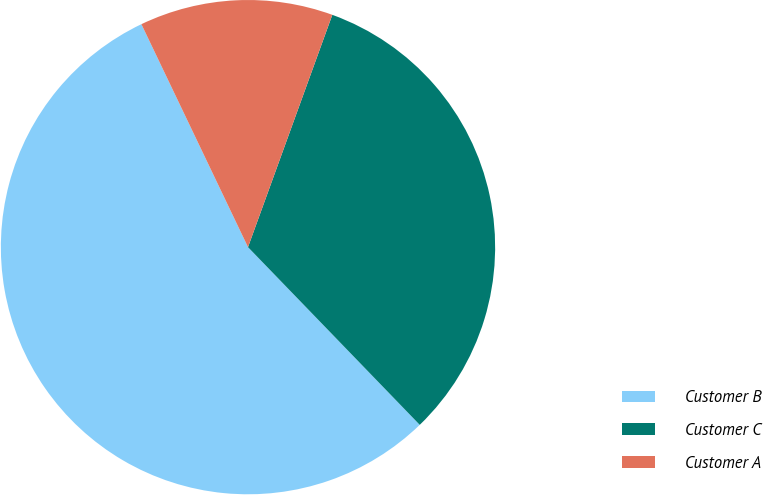Convert chart. <chart><loc_0><loc_0><loc_500><loc_500><pie_chart><fcel>Customer B<fcel>Customer C<fcel>Customer A<nl><fcel>55.13%<fcel>32.23%<fcel>12.64%<nl></chart> 